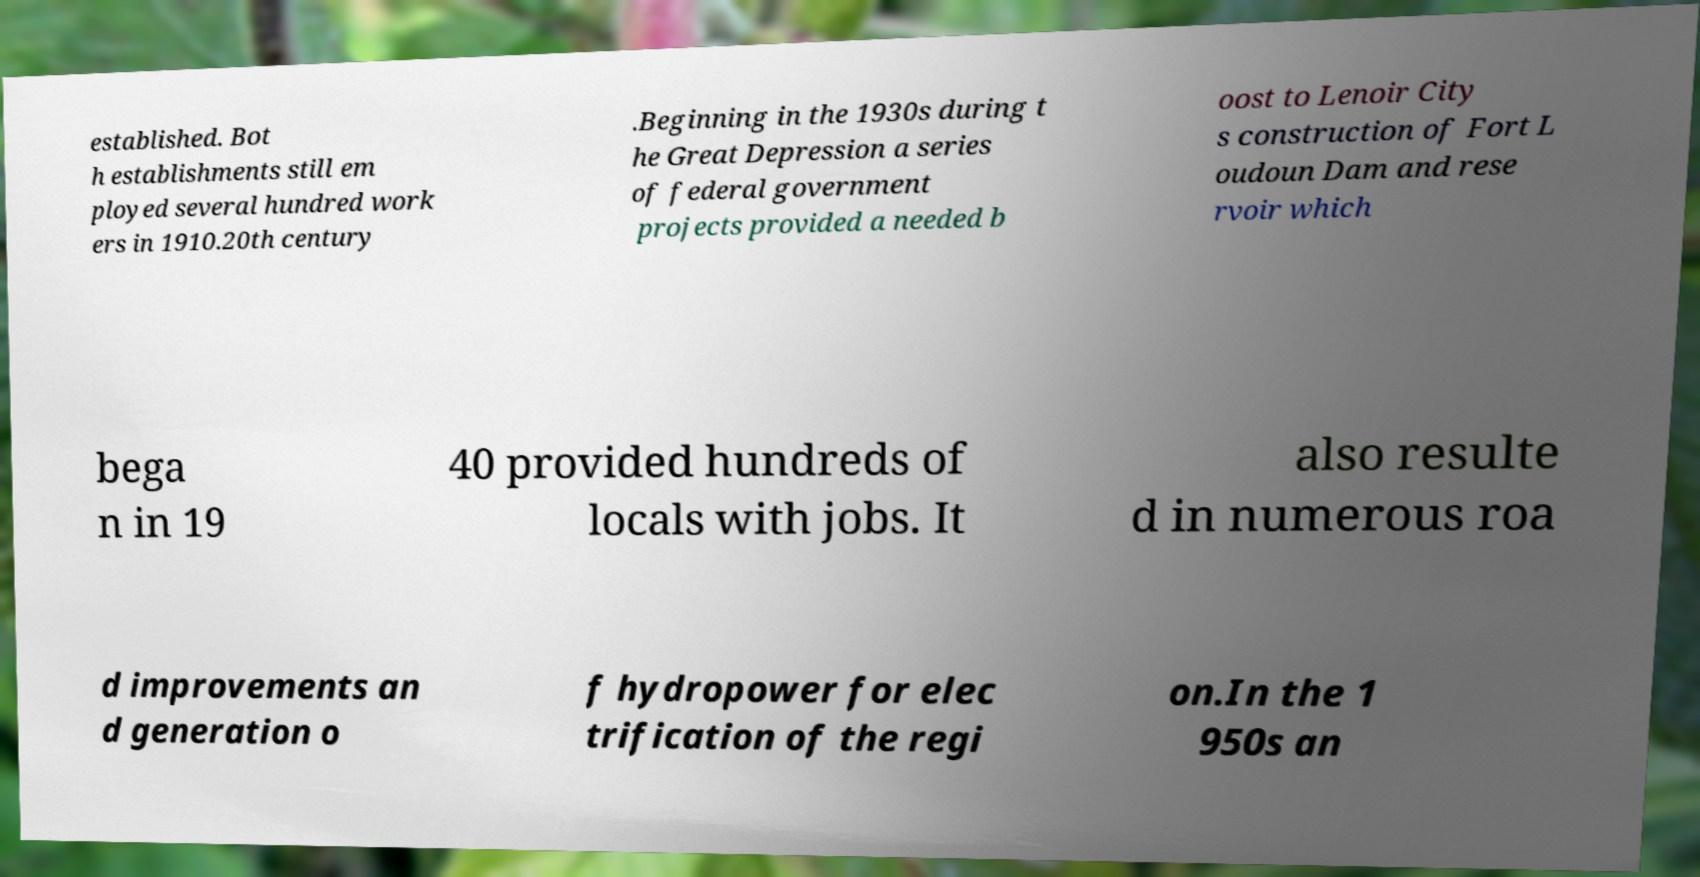Please read and relay the text visible in this image. What does it say? established. Bot h establishments still em ployed several hundred work ers in 1910.20th century .Beginning in the 1930s during t he Great Depression a series of federal government projects provided a needed b oost to Lenoir City s construction of Fort L oudoun Dam and rese rvoir which bega n in 19 40 provided hundreds of locals with jobs. It also resulte d in numerous roa d improvements an d generation o f hydropower for elec trification of the regi on.In the 1 950s an 